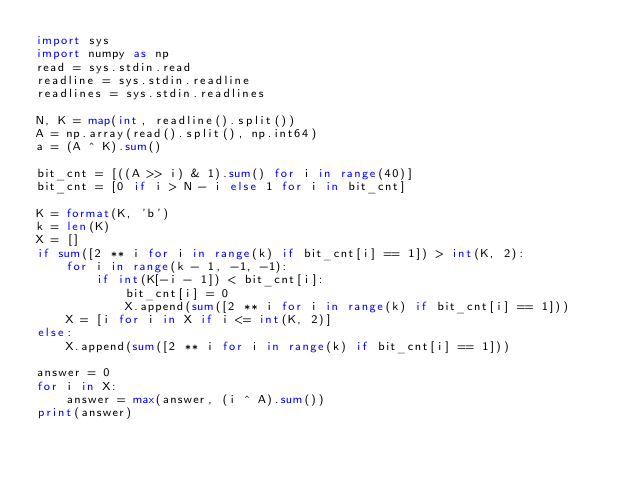<code> <loc_0><loc_0><loc_500><loc_500><_Python_>import sys
import numpy as np
read = sys.stdin.read
readline = sys.stdin.readline
readlines = sys.stdin.readlines

N, K = map(int, readline().split())
A = np.array(read().split(), np.int64)
a = (A ^ K).sum()

bit_cnt = [((A >> i) & 1).sum() for i in range(40)]
bit_cnt = [0 if i > N - i else 1 for i in bit_cnt]

K = format(K, 'b')
k = len(K)
X = []
if sum([2 ** i for i in range(k) if bit_cnt[i] == 1]) > int(K, 2):
    for i in range(k - 1, -1, -1):
        if int(K[-i - 1]) < bit_cnt[i]:
            bit_cnt[i] = 0
            X.append(sum([2 ** i for i in range(k) if bit_cnt[i] == 1]))
    X = [i for i in X if i <= int(K, 2)]
else:
    X.append(sum([2 ** i for i in range(k) if bit_cnt[i] == 1]))

answer = 0
for i in X:
    answer = max(answer, (i ^ A).sum())
print(answer)</code> 